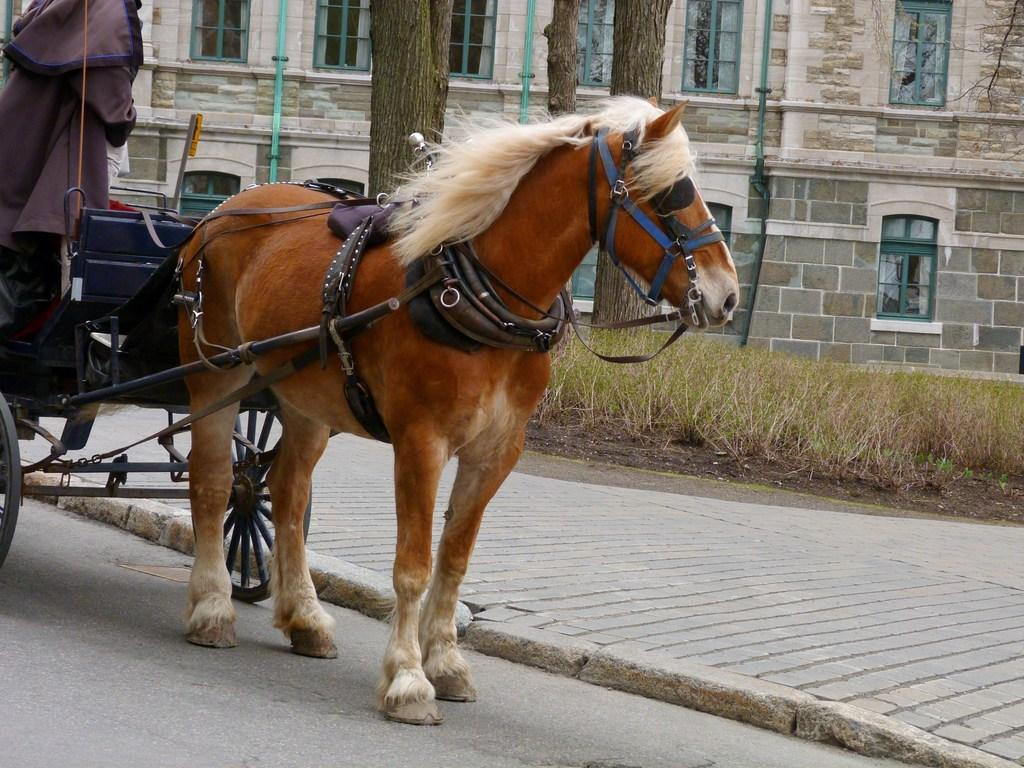What type of vehicle is in the image? There is a horse cart in the image. Who is on the horse cart? A person is standing on the horse cart. What can be seen in the distance behind the horse cart? There is a path, trees, and a building visible in the background of the image. How many needles are scattered on the sand in the image? There is no sand or needles present in the image. 